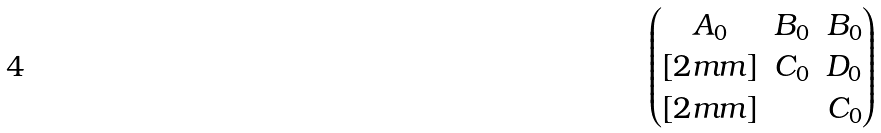Convert formula to latex. <formula><loc_0><loc_0><loc_500><loc_500>\begin{pmatrix} A _ { 0 } & B _ { 0 } & B _ { 0 } \\ [ 2 m m ] & C _ { 0 } & D _ { 0 } \\ [ 2 m m ] & & C _ { 0 } \end{pmatrix}</formula> 